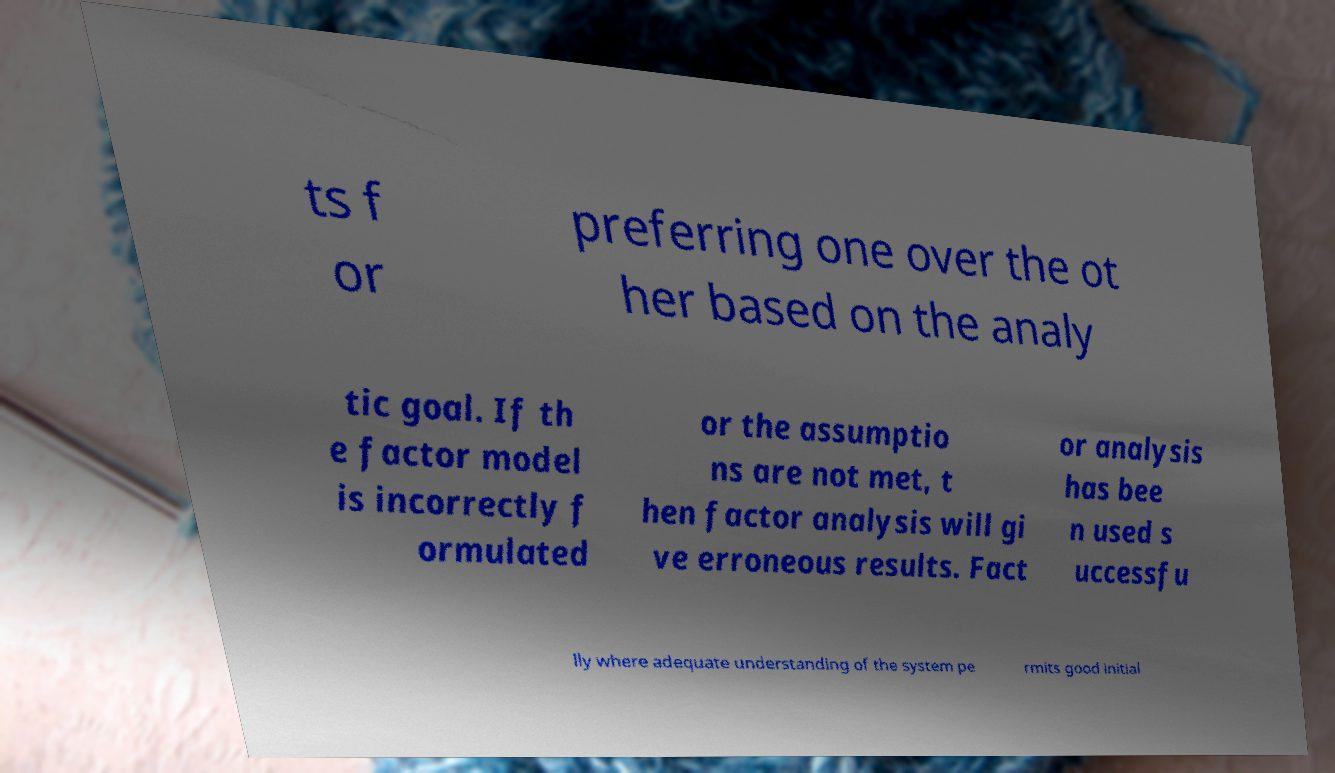Could you extract and type out the text from this image? ts f or preferring one over the ot her based on the analy tic goal. If th e factor model is incorrectly f ormulated or the assumptio ns are not met, t hen factor analysis will gi ve erroneous results. Fact or analysis has bee n used s uccessfu lly where adequate understanding of the system pe rmits good initial 